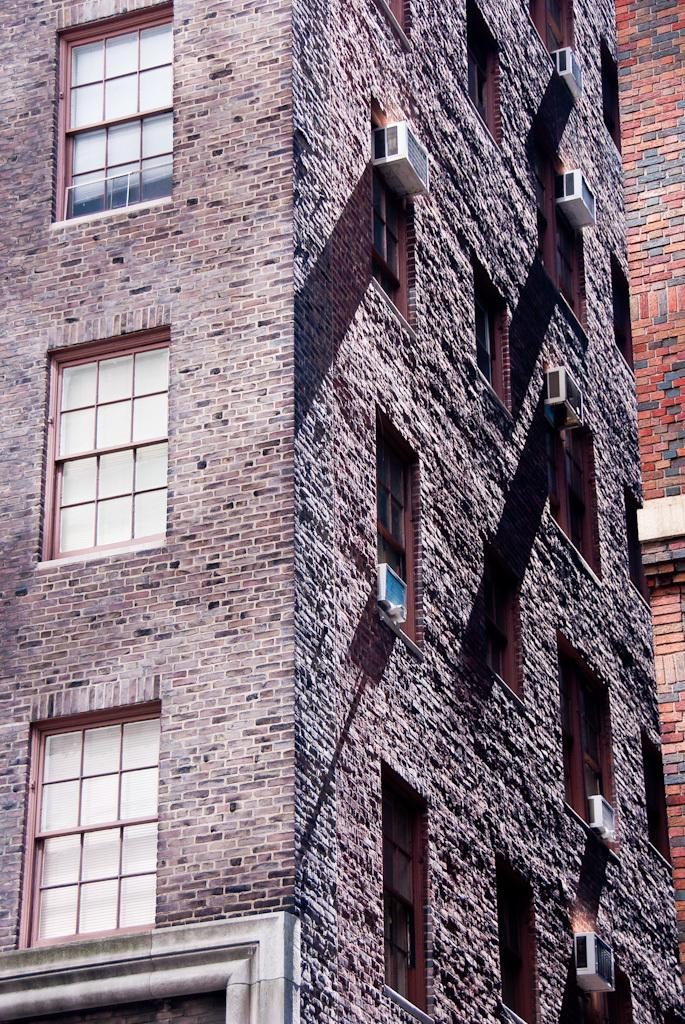What type of structure is visible in the image? There is a building in the image. What features can be seen on the building? The building has windows and AC units. What type of amusement can be seen at the seashore in the image? There is no amusement or seashore present in the image; it features a building with windows and AC units. 